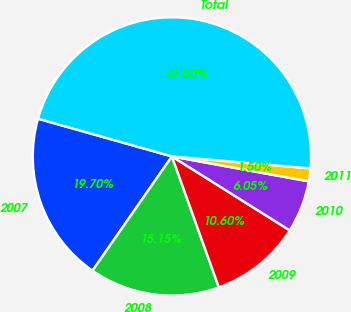<chart> <loc_0><loc_0><loc_500><loc_500><pie_chart><fcel>2007<fcel>2008<fcel>2009<fcel>2010<fcel>2011<fcel>Total<nl><fcel>19.7%<fcel>15.15%<fcel>10.6%<fcel>6.05%<fcel>1.5%<fcel>47.0%<nl></chart> 